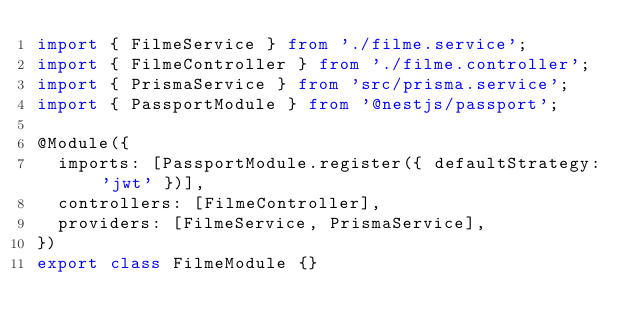Convert code to text. <code><loc_0><loc_0><loc_500><loc_500><_TypeScript_>import { FilmeService } from './filme.service';
import { FilmeController } from './filme.controller';
import { PrismaService } from 'src/prisma.service';
import { PassportModule } from '@nestjs/passport';

@Module({
  imports: [PassportModule.register({ defaultStrategy: 'jwt' })],
  controllers: [FilmeController],
  providers: [FilmeService, PrismaService],
})
export class FilmeModule {}
</code> 